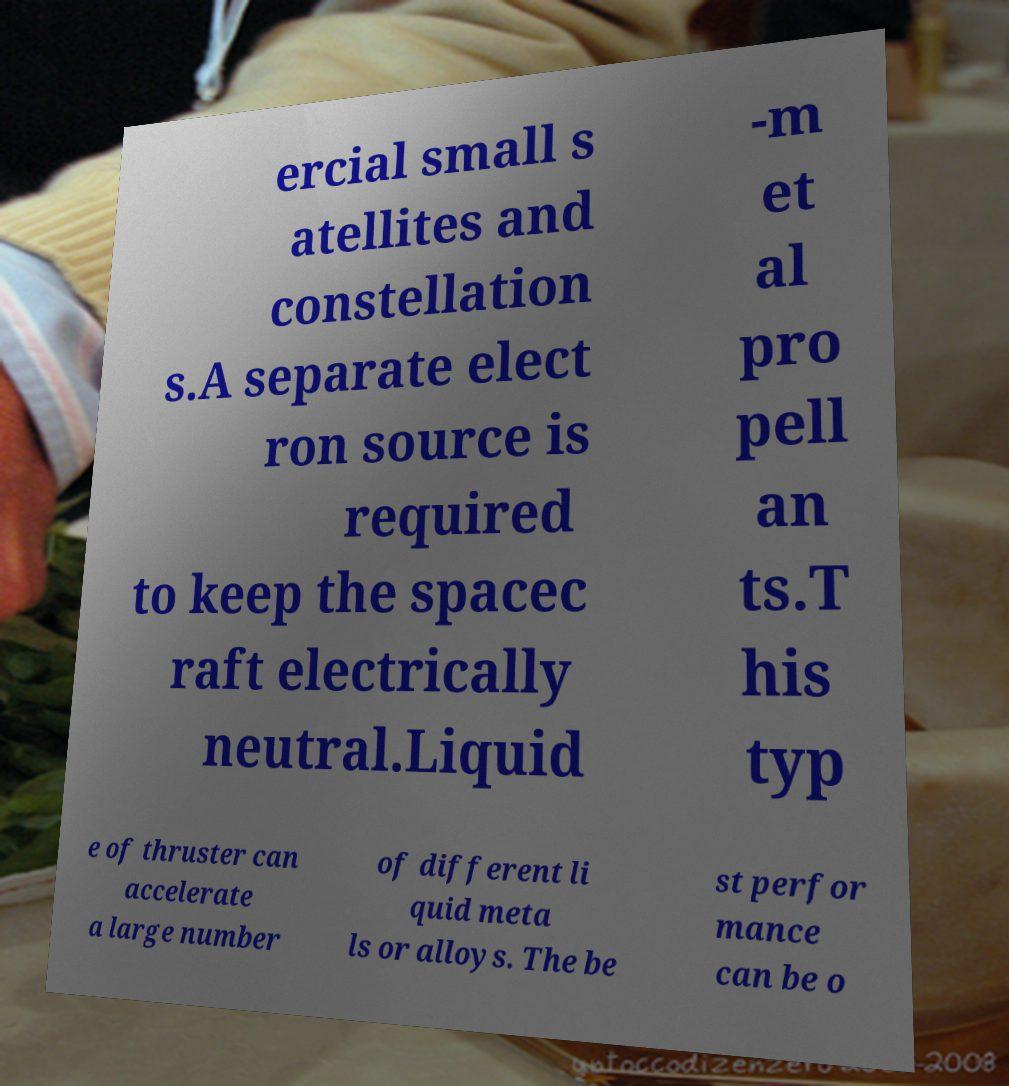Please read and relay the text visible in this image. What does it say? ercial small s atellites and constellation s.A separate elect ron source is required to keep the spacec raft electrically neutral.Liquid -m et al pro pell an ts.T his typ e of thruster can accelerate a large number of different li quid meta ls or alloys. The be st perfor mance can be o 